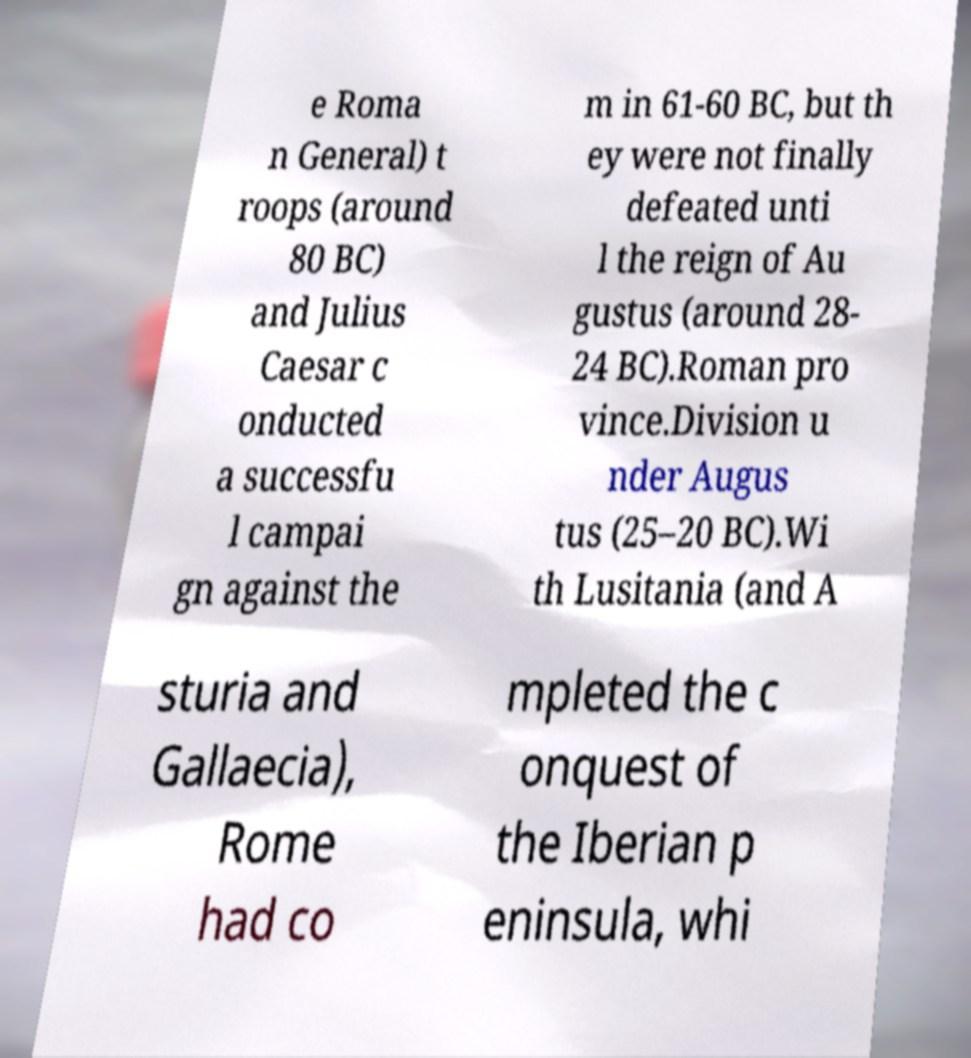Could you assist in decoding the text presented in this image and type it out clearly? e Roma n General) t roops (around 80 BC) and Julius Caesar c onducted a successfu l campai gn against the m in 61-60 BC, but th ey were not finally defeated unti l the reign of Au gustus (around 28- 24 BC).Roman pro vince.Division u nder Augus tus (25–20 BC).Wi th Lusitania (and A sturia and Gallaecia), Rome had co mpleted the c onquest of the Iberian p eninsula, whi 